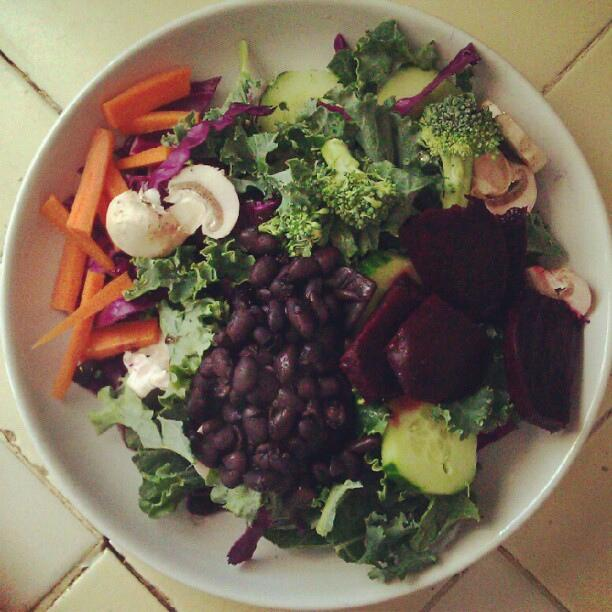What are the sliced red vegetables on the right side of dish called? Please explain your reasoning. beets. The vegetables are known as beets since they're ruby red. 